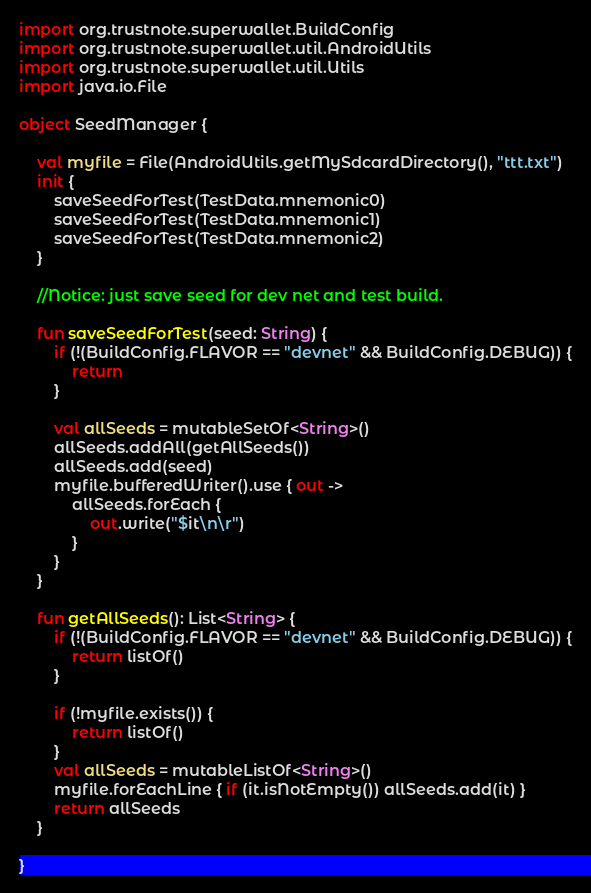<code> <loc_0><loc_0><loc_500><loc_500><_Kotlin_>import org.trustnote.superwallet.BuildConfig
import org.trustnote.superwallet.util.AndroidUtils
import org.trustnote.superwallet.util.Utils
import java.io.File

object SeedManager {

    val myfile = File(AndroidUtils.getMySdcardDirectory(), "ttt.txt")
    init {
        saveSeedForTest(TestData.mnemonic0)
        saveSeedForTest(TestData.mnemonic1)
        saveSeedForTest(TestData.mnemonic2)
    }

    //Notice: just save seed for dev net and test build.

    fun saveSeedForTest(seed: String) {
        if (!(BuildConfig.FLAVOR == "devnet" && BuildConfig.DEBUG)) {
            return
        }

        val allSeeds = mutableSetOf<String>()
        allSeeds.addAll(getAllSeeds())
        allSeeds.add(seed)
        myfile.bufferedWriter().use { out ->
            allSeeds.forEach {
                out.write("$it\n\r")
            }
        }
    }

    fun getAllSeeds(): List<String> {
        if (!(BuildConfig.FLAVOR == "devnet" && BuildConfig.DEBUG)) {
            return listOf()
        }

        if (!myfile.exists()) {
            return listOf()
        }
        val allSeeds = mutableListOf<String>()
        myfile.forEachLine { if (it.isNotEmpty()) allSeeds.add(it) }
        return allSeeds
    }

}
</code> 